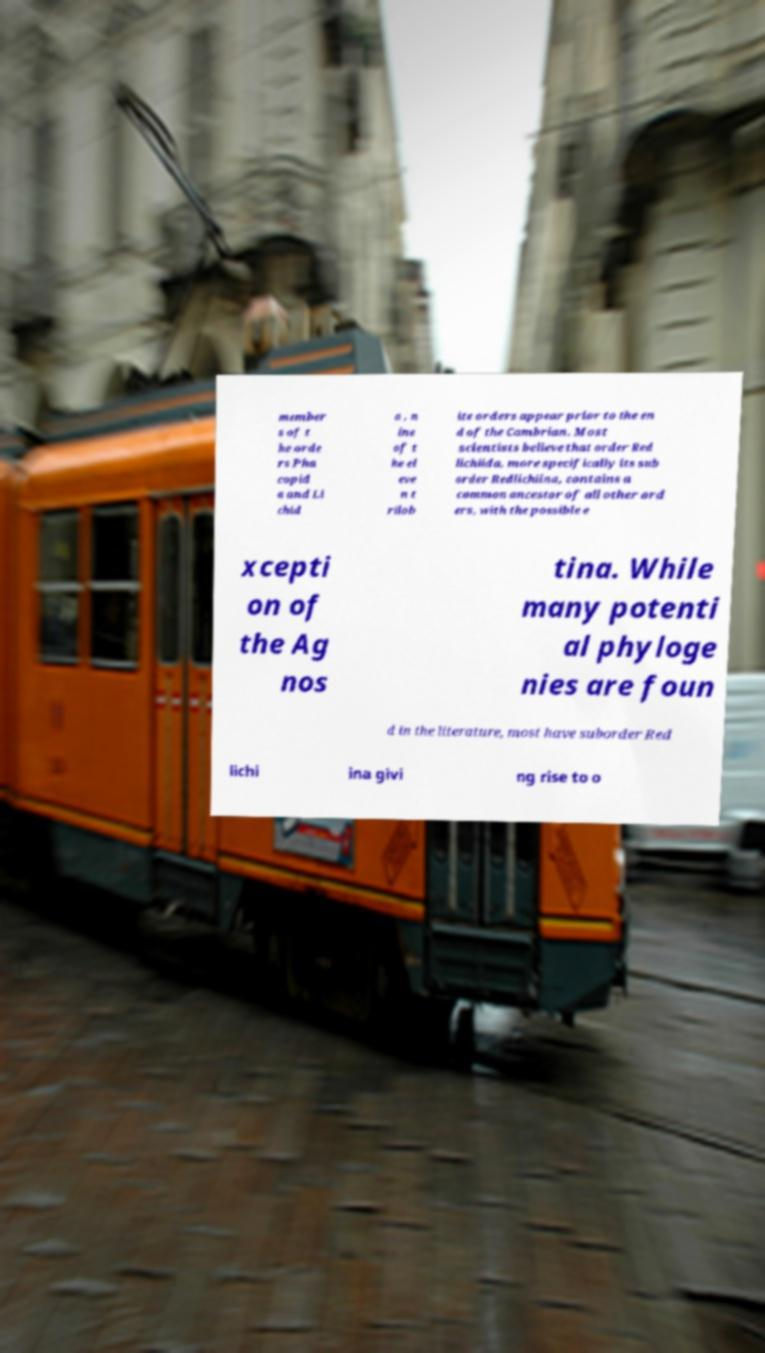Please identify and transcribe the text found in this image. member s of t he orde rs Pha copid a and Li chid a , n ine of t he el eve n t rilob ite orders appear prior to the en d of the Cambrian. Most scientists believe that order Red lichiida, more specifically its sub order Redlichiina, contains a common ancestor of all other ord ers, with the possible e xcepti on of the Ag nos tina. While many potenti al phyloge nies are foun d in the literature, most have suborder Red lichi ina givi ng rise to o 